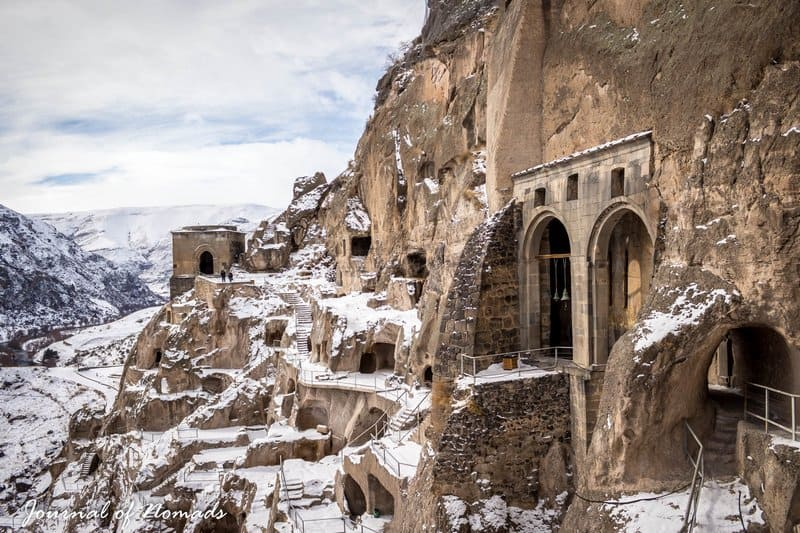Can you explain how the structure of the monastery integrates with the natural environment? Absolutely. The Vardzia cave monastery is a remarkable example of eco-architecture, seamlessly integrated into the cliff’s natural contours. The builders excavated the church and residential quarters directly into the rock, using the natural curvature to provide stability and insulation. This integration not only camouflaged the structure from potential invaders but also maintained a consistent internal temperature, critical for the harsh winters and hot summers characteristic of the region. 